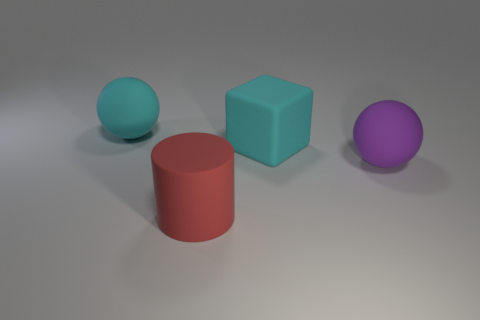Are there the same number of cyan matte things that are in front of the purple matte sphere and big objects on the left side of the cyan rubber sphere?
Give a very brief answer. Yes. What color is the other large thing that is the same shape as the purple thing?
Keep it short and to the point. Cyan. Is there anything else of the same color as the rubber block?
Keep it short and to the point. Yes. How many matte objects are either large cyan objects or tiny gray cubes?
Keep it short and to the point. 2. Does the large matte cylinder have the same color as the matte block?
Make the answer very short. No. Are there more large purple spheres behind the cyan rubber sphere than large purple spheres?
Offer a very short reply. No. How many other objects are there of the same material as the cyan cube?
Make the answer very short. 3. What number of small things are gray shiny spheres or matte cylinders?
Provide a succinct answer. 0. Are the large cyan block and the large red object made of the same material?
Provide a succinct answer. Yes. There is a ball that is on the right side of the large red object; how many large purple matte balls are on the right side of it?
Keep it short and to the point. 0. 